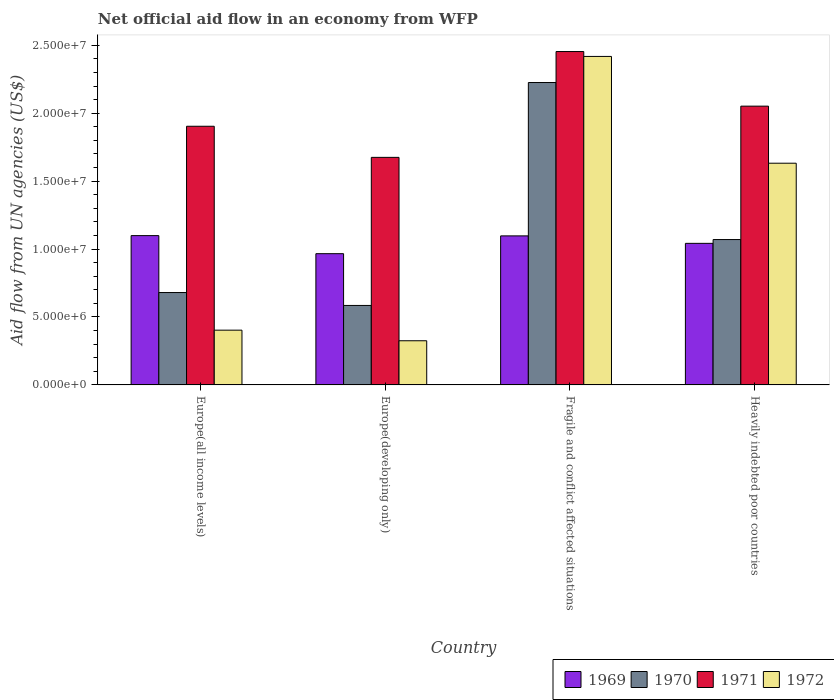Are the number of bars per tick equal to the number of legend labels?
Your response must be concise. Yes. What is the label of the 3rd group of bars from the left?
Your answer should be compact. Fragile and conflict affected situations. What is the net official aid flow in 1969 in Europe(all income levels)?
Your answer should be very brief. 1.10e+07. Across all countries, what is the maximum net official aid flow in 1970?
Keep it short and to the point. 2.23e+07. Across all countries, what is the minimum net official aid flow in 1970?
Offer a very short reply. 5.85e+06. In which country was the net official aid flow in 1972 maximum?
Your answer should be very brief. Fragile and conflict affected situations. In which country was the net official aid flow in 1971 minimum?
Provide a succinct answer. Europe(developing only). What is the total net official aid flow in 1971 in the graph?
Keep it short and to the point. 8.08e+07. What is the difference between the net official aid flow in 1969 in Europe(all income levels) and that in Heavily indebted poor countries?
Offer a terse response. 5.70e+05. What is the difference between the net official aid flow in 1972 in Europe(all income levels) and the net official aid flow in 1969 in Europe(developing only)?
Your answer should be very brief. -5.63e+06. What is the average net official aid flow in 1972 per country?
Your answer should be compact. 1.19e+07. What is the difference between the net official aid flow of/in 1972 and net official aid flow of/in 1971 in Heavily indebted poor countries?
Keep it short and to the point. -4.20e+06. In how many countries, is the net official aid flow in 1970 greater than 14000000 US$?
Your answer should be compact. 1. What is the ratio of the net official aid flow in 1972 in Europe(developing only) to that in Heavily indebted poor countries?
Give a very brief answer. 0.2. Is the net official aid flow in 1971 in Fragile and conflict affected situations less than that in Heavily indebted poor countries?
Ensure brevity in your answer.  No. What is the difference between the highest and the second highest net official aid flow in 1970?
Make the answer very short. 1.16e+07. What is the difference between the highest and the lowest net official aid flow in 1972?
Provide a short and direct response. 2.09e+07. In how many countries, is the net official aid flow in 1970 greater than the average net official aid flow in 1970 taken over all countries?
Provide a short and direct response. 1. Is the sum of the net official aid flow in 1969 in Europe(developing only) and Fragile and conflict affected situations greater than the maximum net official aid flow in 1971 across all countries?
Keep it short and to the point. No. Is it the case that in every country, the sum of the net official aid flow in 1972 and net official aid flow in 1969 is greater than the sum of net official aid flow in 1970 and net official aid flow in 1971?
Make the answer very short. No. What does the 4th bar from the left in Europe(developing only) represents?
Your answer should be very brief. 1972. What does the 4th bar from the right in Europe(all income levels) represents?
Your answer should be very brief. 1969. Is it the case that in every country, the sum of the net official aid flow in 1972 and net official aid flow in 1970 is greater than the net official aid flow in 1971?
Keep it short and to the point. No. How many bars are there?
Provide a short and direct response. 16. Does the graph contain any zero values?
Provide a succinct answer. No. Does the graph contain grids?
Offer a very short reply. No. How many legend labels are there?
Make the answer very short. 4. How are the legend labels stacked?
Provide a short and direct response. Horizontal. What is the title of the graph?
Your answer should be compact. Net official aid flow in an economy from WFP. Does "2001" appear as one of the legend labels in the graph?
Your answer should be very brief. No. What is the label or title of the Y-axis?
Give a very brief answer. Aid flow from UN agencies (US$). What is the Aid flow from UN agencies (US$) in 1969 in Europe(all income levels)?
Ensure brevity in your answer.  1.10e+07. What is the Aid flow from UN agencies (US$) of 1970 in Europe(all income levels)?
Offer a terse response. 6.80e+06. What is the Aid flow from UN agencies (US$) in 1971 in Europe(all income levels)?
Provide a succinct answer. 1.90e+07. What is the Aid flow from UN agencies (US$) in 1972 in Europe(all income levels)?
Your answer should be compact. 4.03e+06. What is the Aid flow from UN agencies (US$) of 1969 in Europe(developing only)?
Your answer should be compact. 9.66e+06. What is the Aid flow from UN agencies (US$) of 1970 in Europe(developing only)?
Provide a short and direct response. 5.85e+06. What is the Aid flow from UN agencies (US$) of 1971 in Europe(developing only)?
Provide a succinct answer. 1.68e+07. What is the Aid flow from UN agencies (US$) in 1972 in Europe(developing only)?
Provide a succinct answer. 3.25e+06. What is the Aid flow from UN agencies (US$) in 1969 in Fragile and conflict affected situations?
Your answer should be compact. 1.10e+07. What is the Aid flow from UN agencies (US$) in 1970 in Fragile and conflict affected situations?
Your answer should be compact. 2.23e+07. What is the Aid flow from UN agencies (US$) in 1971 in Fragile and conflict affected situations?
Give a very brief answer. 2.45e+07. What is the Aid flow from UN agencies (US$) in 1972 in Fragile and conflict affected situations?
Ensure brevity in your answer.  2.42e+07. What is the Aid flow from UN agencies (US$) of 1969 in Heavily indebted poor countries?
Your response must be concise. 1.04e+07. What is the Aid flow from UN agencies (US$) of 1970 in Heavily indebted poor countries?
Your answer should be compact. 1.07e+07. What is the Aid flow from UN agencies (US$) of 1971 in Heavily indebted poor countries?
Offer a terse response. 2.05e+07. What is the Aid flow from UN agencies (US$) of 1972 in Heavily indebted poor countries?
Your answer should be very brief. 1.63e+07. Across all countries, what is the maximum Aid flow from UN agencies (US$) of 1969?
Offer a very short reply. 1.10e+07. Across all countries, what is the maximum Aid flow from UN agencies (US$) in 1970?
Provide a succinct answer. 2.23e+07. Across all countries, what is the maximum Aid flow from UN agencies (US$) of 1971?
Provide a short and direct response. 2.45e+07. Across all countries, what is the maximum Aid flow from UN agencies (US$) in 1972?
Your response must be concise. 2.42e+07. Across all countries, what is the minimum Aid flow from UN agencies (US$) of 1969?
Make the answer very short. 9.66e+06. Across all countries, what is the minimum Aid flow from UN agencies (US$) in 1970?
Offer a very short reply. 5.85e+06. Across all countries, what is the minimum Aid flow from UN agencies (US$) of 1971?
Offer a terse response. 1.68e+07. Across all countries, what is the minimum Aid flow from UN agencies (US$) in 1972?
Keep it short and to the point. 3.25e+06. What is the total Aid flow from UN agencies (US$) of 1969 in the graph?
Ensure brevity in your answer.  4.20e+07. What is the total Aid flow from UN agencies (US$) of 1970 in the graph?
Give a very brief answer. 4.56e+07. What is the total Aid flow from UN agencies (US$) of 1971 in the graph?
Give a very brief answer. 8.08e+07. What is the total Aid flow from UN agencies (US$) of 1972 in the graph?
Provide a succinct answer. 4.78e+07. What is the difference between the Aid flow from UN agencies (US$) in 1969 in Europe(all income levels) and that in Europe(developing only)?
Provide a succinct answer. 1.33e+06. What is the difference between the Aid flow from UN agencies (US$) in 1970 in Europe(all income levels) and that in Europe(developing only)?
Provide a succinct answer. 9.50e+05. What is the difference between the Aid flow from UN agencies (US$) in 1971 in Europe(all income levels) and that in Europe(developing only)?
Make the answer very short. 2.29e+06. What is the difference between the Aid flow from UN agencies (US$) of 1972 in Europe(all income levels) and that in Europe(developing only)?
Offer a very short reply. 7.80e+05. What is the difference between the Aid flow from UN agencies (US$) in 1970 in Europe(all income levels) and that in Fragile and conflict affected situations?
Keep it short and to the point. -1.55e+07. What is the difference between the Aid flow from UN agencies (US$) in 1971 in Europe(all income levels) and that in Fragile and conflict affected situations?
Your answer should be compact. -5.50e+06. What is the difference between the Aid flow from UN agencies (US$) in 1972 in Europe(all income levels) and that in Fragile and conflict affected situations?
Keep it short and to the point. -2.02e+07. What is the difference between the Aid flow from UN agencies (US$) of 1969 in Europe(all income levels) and that in Heavily indebted poor countries?
Ensure brevity in your answer.  5.70e+05. What is the difference between the Aid flow from UN agencies (US$) of 1970 in Europe(all income levels) and that in Heavily indebted poor countries?
Give a very brief answer. -3.90e+06. What is the difference between the Aid flow from UN agencies (US$) in 1971 in Europe(all income levels) and that in Heavily indebted poor countries?
Offer a very short reply. -1.48e+06. What is the difference between the Aid flow from UN agencies (US$) in 1972 in Europe(all income levels) and that in Heavily indebted poor countries?
Give a very brief answer. -1.23e+07. What is the difference between the Aid flow from UN agencies (US$) of 1969 in Europe(developing only) and that in Fragile and conflict affected situations?
Provide a short and direct response. -1.31e+06. What is the difference between the Aid flow from UN agencies (US$) of 1970 in Europe(developing only) and that in Fragile and conflict affected situations?
Provide a short and direct response. -1.64e+07. What is the difference between the Aid flow from UN agencies (US$) of 1971 in Europe(developing only) and that in Fragile and conflict affected situations?
Provide a short and direct response. -7.79e+06. What is the difference between the Aid flow from UN agencies (US$) of 1972 in Europe(developing only) and that in Fragile and conflict affected situations?
Offer a very short reply. -2.09e+07. What is the difference between the Aid flow from UN agencies (US$) in 1969 in Europe(developing only) and that in Heavily indebted poor countries?
Your answer should be very brief. -7.60e+05. What is the difference between the Aid flow from UN agencies (US$) of 1970 in Europe(developing only) and that in Heavily indebted poor countries?
Give a very brief answer. -4.85e+06. What is the difference between the Aid flow from UN agencies (US$) in 1971 in Europe(developing only) and that in Heavily indebted poor countries?
Offer a very short reply. -3.77e+06. What is the difference between the Aid flow from UN agencies (US$) in 1972 in Europe(developing only) and that in Heavily indebted poor countries?
Keep it short and to the point. -1.31e+07. What is the difference between the Aid flow from UN agencies (US$) of 1969 in Fragile and conflict affected situations and that in Heavily indebted poor countries?
Offer a very short reply. 5.50e+05. What is the difference between the Aid flow from UN agencies (US$) of 1970 in Fragile and conflict affected situations and that in Heavily indebted poor countries?
Offer a terse response. 1.16e+07. What is the difference between the Aid flow from UN agencies (US$) in 1971 in Fragile and conflict affected situations and that in Heavily indebted poor countries?
Ensure brevity in your answer.  4.02e+06. What is the difference between the Aid flow from UN agencies (US$) in 1972 in Fragile and conflict affected situations and that in Heavily indebted poor countries?
Your response must be concise. 7.86e+06. What is the difference between the Aid flow from UN agencies (US$) in 1969 in Europe(all income levels) and the Aid flow from UN agencies (US$) in 1970 in Europe(developing only)?
Provide a succinct answer. 5.14e+06. What is the difference between the Aid flow from UN agencies (US$) of 1969 in Europe(all income levels) and the Aid flow from UN agencies (US$) of 1971 in Europe(developing only)?
Offer a very short reply. -5.76e+06. What is the difference between the Aid flow from UN agencies (US$) in 1969 in Europe(all income levels) and the Aid flow from UN agencies (US$) in 1972 in Europe(developing only)?
Your answer should be compact. 7.74e+06. What is the difference between the Aid flow from UN agencies (US$) in 1970 in Europe(all income levels) and the Aid flow from UN agencies (US$) in 1971 in Europe(developing only)?
Your answer should be very brief. -9.95e+06. What is the difference between the Aid flow from UN agencies (US$) in 1970 in Europe(all income levels) and the Aid flow from UN agencies (US$) in 1972 in Europe(developing only)?
Make the answer very short. 3.55e+06. What is the difference between the Aid flow from UN agencies (US$) of 1971 in Europe(all income levels) and the Aid flow from UN agencies (US$) of 1972 in Europe(developing only)?
Your answer should be compact. 1.58e+07. What is the difference between the Aid flow from UN agencies (US$) of 1969 in Europe(all income levels) and the Aid flow from UN agencies (US$) of 1970 in Fragile and conflict affected situations?
Provide a succinct answer. -1.13e+07. What is the difference between the Aid flow from UN agencies (US$) in 1969 in Europe(all income levels) and the Aid flow from UN agencies (US$) in 1971 in Fragile and conflict affected situations?
Your answer should be very brief. -1.36e+07. What is the difference between the Aid flow from UN agencies (US$) of 1969 in Europe(all income levels) and the Aid flow from UN agencies (US$) of 1972 in Fragile and conflict affected situations?
Provide a short and direct response. -1.32e+07. What is the difference between the Aid flow from UN agencies (US$) in 1970 in Europe(all income levels) and the Aid flow from UN agencies (US$) in 1971 in Fragile and conflict affected situations?
Your response must be concise. -1.77e+07. What is the difference between the Aid flow from UN agencies (US$) in 1970 in Europe(all income levels) and the Aid flow from UN agencies (US$) in 1972 in Fragile and conflict affected situations?
Offer a very short reply. -1.74e+07. What is the difference between the Aid flow from UN agencies (US$) of 1971 in Europe(all income levels) and the Aid flow from UN agencies (US$) of 1972 in Fragile and conflict affected situations?
Keep it short and to the point. -5.14e+06. What is the difference between the Aid flow from UN agencies (US$) in 1969 in Europe(all income levels) and the Aid flow from UN agencies (US$) in 1970 in Heavily indebted poor countries?
Offer a very short reply. 2.90e+05. What is the difference between the Aid flow from UN agencies (US$) of 1969 in Europe(all income levels) and the Aid flow from UN agencies (US$) of 1971 in Heavily indebted poor countries?
Your answer should be very brief. -9.53e+06. What is the difference between the Aid flow from UN agencies (US$) in 1969 in Europe(all income levels) and the Aid flow from UN agencies (US$) in 1972 in Heavily indebted poor countries?
Offer a very short reply. -5.33e+06. What is the difference between the Aid flow from UN agencies (US$) in 1970 in Europe(all income levels) and the Aid flow from UN agencies (US$) in 1971 in Heavily indebted poor countries?
Offer a very short reply. -1.37e+07. What is the difference between the Aid flow from UN agencies (US$) of 1970 in Europe(all income levels) and the Aid flow from UN agencies (US$) of 1972 in Heavily indebted poor countries?
Provide a succinct answer. -9.52e+06. What is the difference between the Aid flow from UN agencies (US$) of 1971 in Europe(all income levels) and the Aid flow from UN agencies (US$) of 1972 in Heavily indebted poor countries?
Your response must be concise. 2.72e+06. What is the difference between the Aid flow from UN agencies (US$) of 1969 in Europe(developing only) and the Aid flow from UN agencies (US$) of 1970 in Fragile and conflict affected situations?
Keep it short and to the point. -1.26e+07. What is the difference between the Aid flow from UN agencies (US$) of 1969 in Europe(developing only) and the Aid flow from UN agencies (US$) of 1971 in Fragile and conflict affected situations?
Your answer should be very brief. -1.49e+07. What is the difference between the Aid flow from UN agencies (US$) in 1969 in Europe(developing only) and the Aid flow from UN agencies (US$) in 1972 in Fragile and conflict affected situations?
Ensure brevity in your answer.  -1.45e+07. What is the difference between the Aid flow from UN agencies (US$) of 1970 in Europe(developing only) and the Aid flow from UN agencies (US$) of 1971 in Fragile and conflict affected situations?
Provide a succinct answer. -1.87e+07. What is the difference between the Aid flow from UN agencies (US$) of 1970 in Europe(developing only) and the Aid flow from UN agencies (US$) of 1972 in Fragile and conflict affected situations?
Your answer should be compact. -1.83e+07. What is the difference between the Aid flow from UN agencies (US$) in 1971 in Europe(developing only) and the Aid flow from UN agencies (US$) in 1972 in Fragile and conflict affected situations?
Offer a very short reply. -7.43e+06. What is the difference between the Aid flow from UN agencies (US$) in 1969 in Europe(developing only) and the Aid flow from UN agencies (US$) in 1970 in Heavily indebted poor countries?
Make the answer very short. -1.04e+06. What is the difference between the Aid flow from UN agencies (US$) in 1969 in Europe(developing only) and the Aid flow from UN agencies (US$) in 1971 in Heavily indebted poor countries?
Make the answer very short. -1.09e+07. What is the difference between the Aid flow from UN agencies (US$) of 1969 in Europe(developing only) and the Aid flow from UN agencies (US$) of 1972 in Heavily indebted poor countries?
Offer a very short reply. -6.66e+06. What is the difference between the Aid flow from UN agencies (US$) of 1970 in Europe(developing only) and the Aid flow from UN agencies (US$) of 1971 in Heavily indebted poor countries?
Keep it short and to the point. -1.47e+07. What is the difference between the Aid flow from UN agencies (US$) of 1970 in Europe(developing only) and the Aid flow from UN agencies (US$) of 1972 in Heavily indebted poor countries?
Offer a very short reply. -1.05e+07. What is the difference between the Aid flow from UN agencies (US$) in 1971 in Europe(developing only) and the Aid flow from UN agencies (US$) in 1972 in Heavily indebted poor countries?
Give a very brief answer. 4.30e+05. What is the difference between the Aid flow from UN agencies (US$) in 1969 in Fragile and conflict affected situations and the Aid flow from UN agencies (US$) in 1970 in Heavily indebted poor countries?
Give a very brief answer. 2.70e+05. What is the difference between the Aid flow from UN agencies (US$) of 1969 in Fragile and conflict affected situations and the Aid flow from UN agencies (US$) of 1971 in Heavily indebted poor countries?
Your answer should be compact. -9.55e+06. What is the difference between the Aid flow from UN agencies (US$) of 1969 in Fragile and conflict affected situations and the Aid flow from UN agencies (US$) of 1972 in Heavily indebted poor countries?
Your answer should be compact. -5.35e+06. What is the difference between the Aid flow from UN agencies (US$) in 1970 in Fragile and conflict affected situations and the Aid flow from UN agencies (US$) in 1971 in Heavily indebted poor countries?
Your response must be concise. 1.74e+06. What is the difference between the Aid flow from UN agencies (US$) of 1970 in Fragile and conflict affected situations and the Aid flow from UN agencies (US$) of 1972 in Heavily indebted poor countries?
Your answer should be compact. 5.94e+06. What is the difference between the Aid flow from UN agencies (US$) in 1971 in Fragile and conflict affected situations and the Aid flow from UN agencies (US$) in 1972 in Heavily indebted poor countries?
Your response must be concise. 8.22e+06. What is the average Aid flow from UN agencies (US$) of 1969 per country?
Keep it short and to the point. 1.05e+07. What is the average Aid flow from UN agencies (US$) in 1970 per country?
Provide a succinct answer. 1.14e+07. What is the average Aid flow from UN agencies (US$) of 1971 per country?
Your response must be concise. 2.02e+07. What is the average Aid flow from UN agencies (US$) of 1972 per country?
Make the answer very short. 1.19e+07. What is the difference between the Aid flow from UN agencies (US$) of 1969 and Aid flow from UN agencies (US$) of 1970 in Europe(all income levels)?
Ensure brevity in your answer.  4.19e+06. What is the difference between the Aid flow from UN agencies (US$) in 1969 and Aid flow from UN agencies (US$) in 1971 in Europe(all income levels)?
Your response must be concise. -8.05e+06. What is the difference between the Aid flow from UN agencies (US$) in 1969 and Aid flow from UN agencies (US$) in 1972 in Europe(all income levels)?
Provide a short and direct response. 6.96e+06. What is the difference between the Aid flow from UN agencies (US$) in 1970 and Aid flow from UN agencies (US$) in 1971 in Europe(all income levels)?
Give a very brief answer. -1.22e+07. What is the difference between the Aid flow from UN agencies (US$) in 1970 and Aid flow from UN agencies (US$) in 1972 in Europe(all income levels)?
Your response must be concise. 2.77e+06. What is the difference between the Aid flow from UN agencies (US$) in 1971 and Aid flow from UN agencies (US$) in 1972 in Europe(all income levels)?
Your answer should be compact. 1.50e+07. What is the difference between the Aid flow from UN agencies (US$) of 1969 and Aid flow from UN agencies (US$) of 1970 in Europe(developing only)?
Your response must be concise. 3.81e+06. What is the difference between the Aid flow from UN agencies (US$) in 1969 and Aid flow from UN agencies (US$) in 1971 in Europe(developing only)?
Make the answer very short. -7.09e+06. What is the difference between the Aid flow from UN agencies (US$) in 1969 and Aid flow from UN agencies (US$) in 1972 in Europe(developing only)?
Ensure brevity in your answer.  6.41e+06. What is the difference between the Aid flow from UN agencies (US$) of 1970 and Aid flow from UN agencies (US$) of 1971 in Europe(developing only)?
Provide a succinct answer. -1.09e+07. What is the difference between the Aid flow from UN agencies (US$) in 1970 and Aid flow from UN agencies (US$) in 1972 in Europe(developing only)?
Keep it short and to the point. 2.60e+06. What is the difference between the Aid flow from UN agencies (US$) of 1971 and Aid flow from UN agencies (US$) of 1972 in Europe(developing only)?
Your response must be concise. 1.35e+07. What is the difference between the Aid flow from UN agencies (US$) in 1969 and Aid flow from UN agencies (US$) in 1970 in Fragile and conflict affected situations?
Make the answer very short. -1.13e+07. What is the difference between the Aid flow from UN agencies (US$) of 1969 and Aid flow from UN agencies (US$) of 1971 in Fragile and conflict affected situations?
Provide a succinct answer. -1.36e+07. What is the difference between the Aid flow from UN agencies (US$) in 1969 and Aid flow from UN agencies (US$) in 1972 in Fragile and conflict affected situations?
Your response must be concise. -1.32e+07. What is the difference between the Aid flow from UN agencies (US$) of 1970 and Aid flow from UN agencies (US$) of 1971 in Fragile and conflict affected situations?
Provide a succinct answer. -2.28e+06. What is the difference between the Aid flow from UN agencies (US$) in 1970 and Aid flow from UN agencies (US$) in 1972 in Fragile and conflict affected situations?
Your response must be concise. -1.92e+06. What is the difference between the Aid flow from UN agencies (US$) in 1971 and Aid flow from UN agencies (US$) in 1972 in Fragile and conflict affected situations?
Keep it short and to the point. 3.60e+05. What is the difference between the Aid flow from UN agencies (US$) of 1969 and Aid flow from UN agencies (US$) of 1970 in Heavily indebted poor countries?
Keep it short and to the point. -2.80e+05. What is the difference between the Aid flow from UN agencies (US$) in 1969 and Aid flow from UN agencies (US$) in 1971 in Heavily indebted poor countries?
Provide a succinct answer. -1.01e+07. What is the difference between the Aid flow from UN agencies (US$) in 1969 and Aid flow from UN agencies (US$) in 1972 in Heavily indebted poor countries?
Keep it short and to the point. -5.90e+06. What is the difference between the Aid flow from UN agencies (US$) in 1970 and Aid flow from UN agencies (US$) in 1971 in Heavily indebted poor countries?
Your answer should be very brief. -9.82e+06. What is the difference between the Aid flow from UN agencies (US$) of 1970 and Aid flow from UN agencies (US$) of 1972 in Heavily indebted poor countries?
Provide a short and direct response. -5.62e+06. What is the difference between the Aid flow from UN agencies (US$) of 1971 and Aid flow from UN agencies (US$) of 1972 in Heavily indebted poor countries?
Provide a short and direct response. 4.20e+06. What is the ratio of the Aid flow from UN agencies (US$) in 1969 in Europe(all income levels) to that in Europe(developing only)?
Ensure brevity in your answer.  1.14. What is the ratio of the Aid flow from UN agencies (US$) of 1970 in Europe(all income levels) to that in Europe(developing only)?
Your answer should be compact. 1.16. What is the ratio of the Aid flow from UN agencies (US$) in 1971 in Europe(all income levels) to that in Europe(developing only)?
Ensure brevity in your answer.  1.14. What is the ratio of the Aid flow from UN agencies (US$) of 1972 in Europe(all income levels) to that in Europe(developing only)?
Offer a terse response. 1.24. What is the ratio of the Aid flow from UN agencies (US$) of 1969 in Europe(all income levels) to that in Fragile and conflict affected situations?
Provide a succinct answer. 1. What is the ratio of the Aid flow from UN agencies (US$) in 1970 in Europe(all income levels) to that in Fragile and conflict affected situations?
Your answer should be compact. 0.31. What is the ratio of the Aid flow from UN agencies (US$) of 1971 in Europe(all income levels) to that in Fragile and conflict affected situations?
Your answer should be compact. 0.78. What is the ratio of the Aid flow from UN agencies (US$) in 1972 in Europe(all income levels) to that in Fragile and conflict affected situations?
Your answer should be very brief. 0.17. What is the ratio of the Aid flow from UN agencies (US$) in 1969 in Europe(all income levels) to that in Heavily indebted poor countries?
Make the answer very short. 1.05. What is the ratio of the Aid flow from UN agencies (US$) in 1970 in Europe(all income levels) to that in Heavily indebted poor countries?
Offer a terse response. 0.64. What is the ratio of the Aid flow from UN agencies (US$) in 1971 in Europe(all income levels) to that in Heavily indebted poor countries?
Make the answer very short. 0.93. What is the ratio of the Aid flow from UN agencies (US$) of 1972 in Europe(all income levels) to that in Heavily indebted poor countries?
Ensure brevity in your answer.  0.25. What is the ratio of the Aid flow from UN agencies (US$) in 1969 in Europe(developing only) to that in Fragile and conflict affected situations?
Offer a terse response. 0.88. What is the ratio of the Aid flow from UN agencies (US$) of 1970 in Europe(developing only) to that in Fragile and conflict affected situations?
Keep it short and to the point. 0.26. What is the ratio of the Aid flow from UN agencies (US$) of 1971 in Europe(developing only) to that in Fragile and conflict affected situations?
Your answer should be compact. 0.68. What is the ratio of the Aid flow from UN agencies (US$) of 1972 in Europe(developing only) to that in Fragile and conflict affected situations?
Ensure brevity in your answer.  0.13. What is the ratio of the Aid flow from UN agencies (US$) of 1969 in Europe(developing only) to that in Heavily indebted poor countries?
Offer a terse response. 0.93. What is the ratio of the Aid flow from UN agencies (US$) in 1970 in Europe(developing only) to that in Heavily indebted poor countries?
Make the answer very short. 0.55. What is the ratio of the Aid flow from UN agencies (US$) in 1971 in Europe(developing only) to that in Heavily indebted poor countries?
Provide a short and direct response. 0.82. What is the ratio of the Aid flow from UN agencies (US$) of 1972 in Europe(developing only) to that in Heavily indebted poor countries?
Keep it short and to the point. 0.2. What is the ratio of the Aid flow from UN agencies (US$) in 1969 in Fragile and conflict affected situations to that in Heavily indebted poor countries?
Your answer should be compact. 1.05. What is the ratio of the Aid flow from UN agencies (US$) of 1970 in Fragile and conflict affected situations to that in Heavily indebted poor countries?
Ensure brevity in your answer.  2.08. What is the ratio of the Aid flow from UN agencies (US$) of 1971 in Fragile and conflict affected situations to that in Heavily indebted poor countries?
Provide a short and direct response. 1.2. What is the ratio of the Aid flow from UN agencies (US$) in 1972 in Fragile and conflict affected situations to that in Heavily indebted poor countries?
Provide a short and direct response. 1.48. What is the difference between the highest and the second highest Aid flow from UN agencies (US$) in 1970?
Ensure brevity in your answer.  1.16e+07. What is the difference between the highest and the second highest Aid flow from UN agencies (US$) of 1971?
Offer a terse response. 4.02e+06. What is the difference between the highest and the second highest Aid flow from UN agencies (US$) in 1972?
Your answer should be compact. 7.86e+06. What is the difference between the highest and the lowest Aid flow from UN agencies (US$) in 1969?
Ensure brevity in your answer.  1.33e+06. What is the difference between the highest and the lowest Aid flow from UN agencies (US$) in 1970?
Your answer should be compact. 1.64e+07. What is the difference between the highest and the lowest Aid flow from UN agencies (US$) of 1971?
Provide a succinct answer. 7.79e+06. What is the difference between the highest and the lowest Aid flow from UN agencies (US$) in 1972?
Your answer should be very brief. 2.09e+07. 